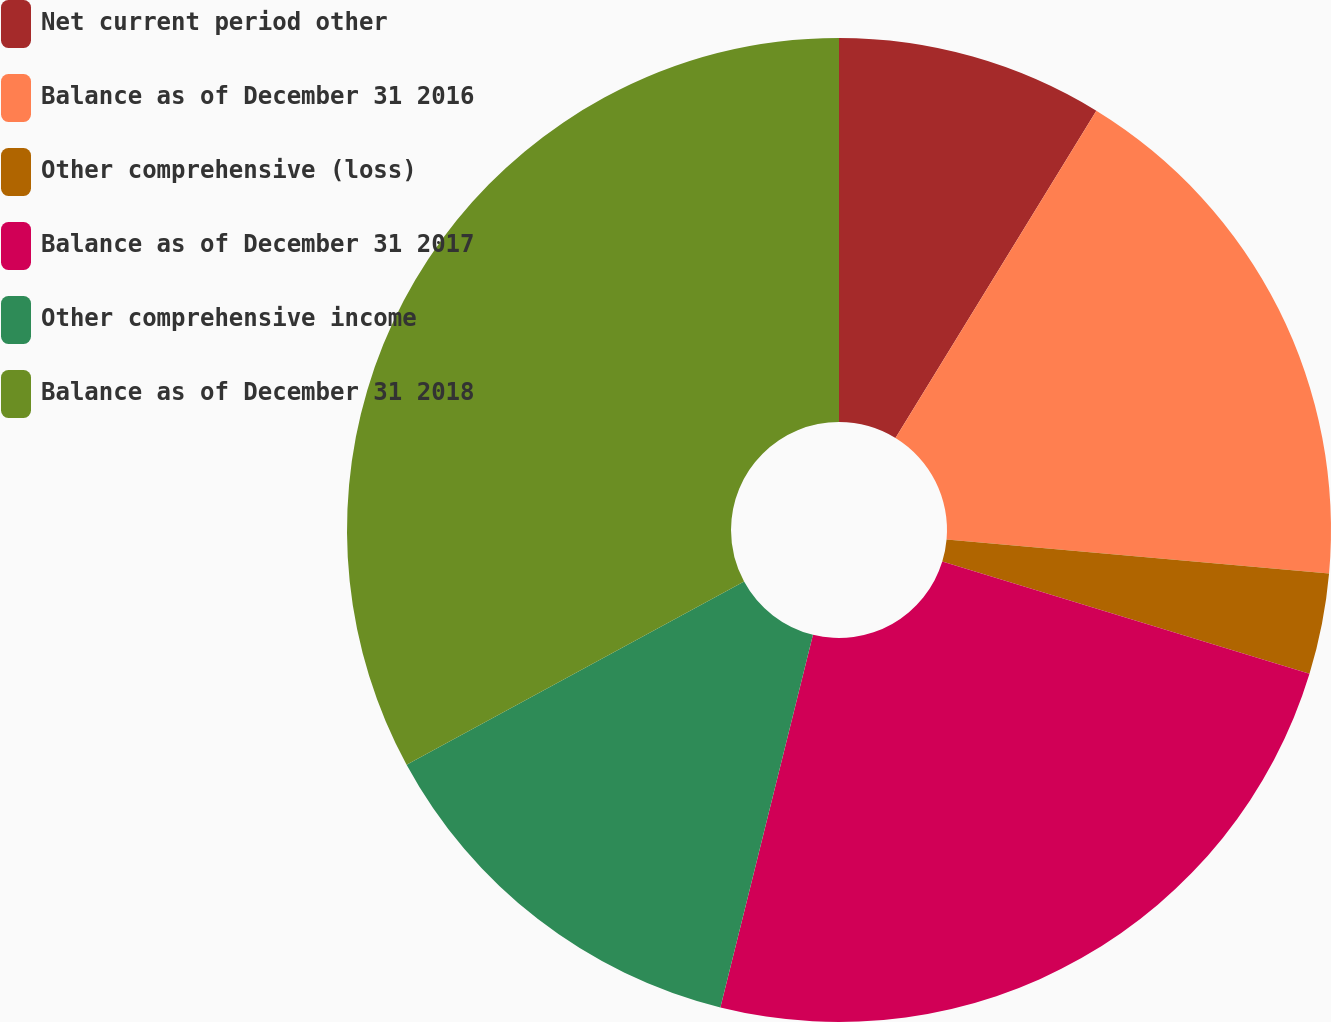Convert chart to OTSL. <chart><loc_0><loc_0><loc_500><loc_500><pie_chart><fcel>Net current period other<fcel>Balance as of December 31 2016<fcel>Other comprehensive (loss)<fcel>Balance as of December 31 2017<fcel>Other comprehensive income<fcel>Balance as of December 31 2018<nl><fcel>8.76%<fcel>17.65%<fcel>3.31%<fcel>24.15%<fcel>13.21%<fcel>32.91%<nl></chart> 